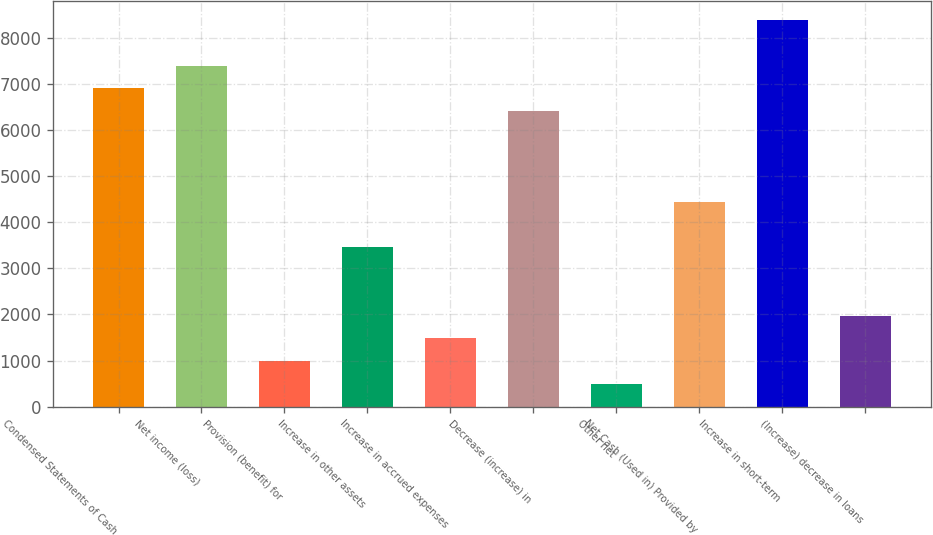Convert chart. <chart><loc_0><loc_0><loc_500><loc_500><bar_chart><fcel>Condensed Statements of Cash<fcel>Net income (loss)<fcel>Provision (benefit) for<fcel>Increase in other assets<fcel>Increase in accrued expenses<fcel>Decrease (increase) in<fcel>Other net<fcel>Net Cash (Used in) Provided by<fcel>Increase in short-term<fcel>(Increase) decrease in loans<nl><fcel>6901.8<fcel>7394.5<fcel>989.4<fcel>3452.9<fcel>1482.1<fcel>6409.1<fcel>496.7<fcel>4438.3<fcel>8379.9<fcel>1974.8<nl></chart> 